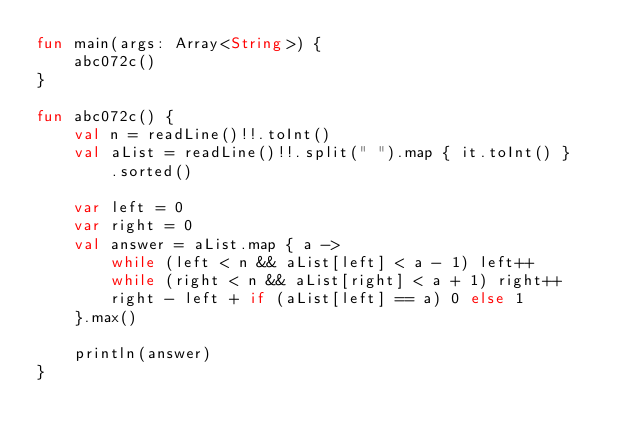<code> <loc_0><loc_0><loc_500><loc_500><_Kotlin_>fun main(args: Array<String>) {
    abc072c()
}

fun abc072c() {
    val n = readLine()!!.toInt()
    val aList = readLine()!!.split(" ").map { it.toInt() }
        .sorted()

    var left = 0
    var right = 0
    val answer = aList.map { a ->
        while (left < n && aList[left] < a - 1) left++
        while (right < n && aList[right] < a + 1) right++
        right - left + if (aList[left] == a) 0 else 1
    }.max()

    println(answer)
}
</code> 